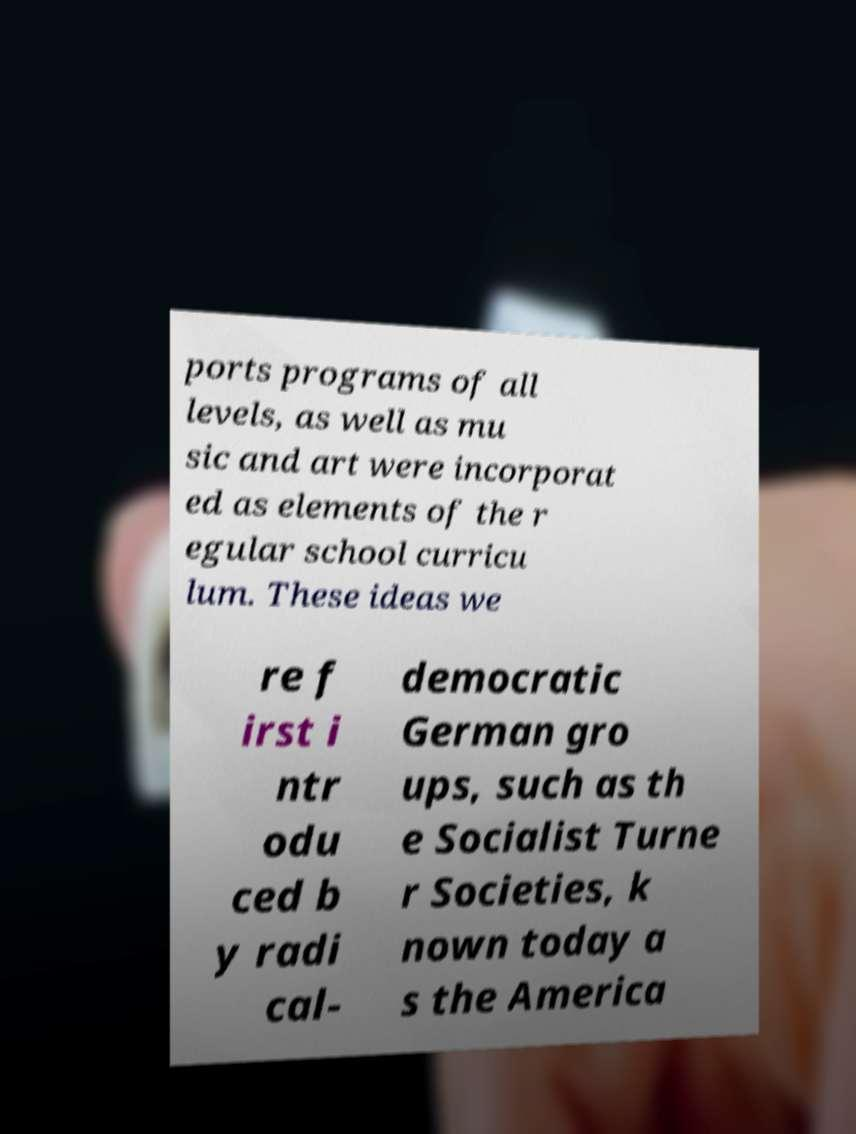Please identify and transcribe the text found in this image. ports programs of all levels, as well as mu sic and art were incorporat ed as elements of the r egular school curricu lum. These ideas we re f irst i ntr odu ced b y radi cal- democratic German gro ups, such as th e Socialist Turne r Societies, k nown today a s the America 